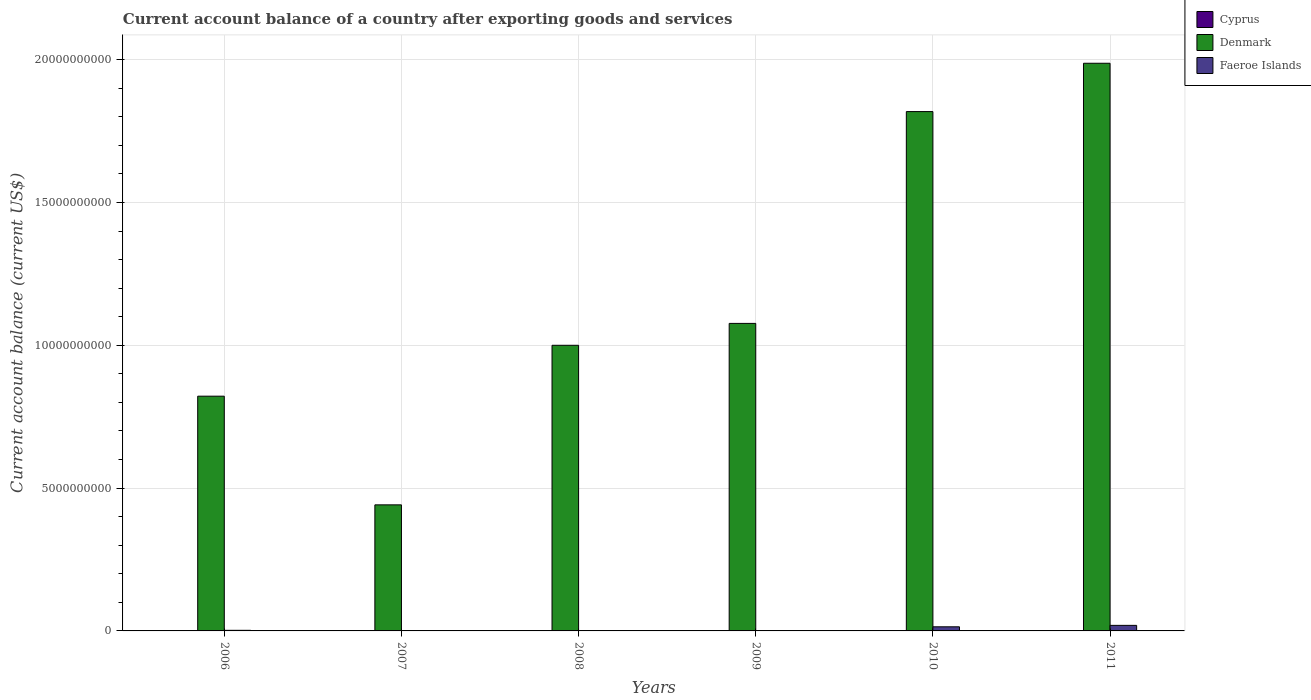How many bars are there on the 4th tick from the left?
Give a very brief answer. 1. What is the label of the 4th group of bars from the left?
Your answer should be very brief. 2009. In how many cases, is the number of bars for a given year not equal to the number of legend labels?
Your response must be concise. 6. Across all years, what is the maximum account balance in Faeroe Islands?
Provide a succinct answer. 1.94e+08. Across all years, what is the minimum account balance in Faeroe Islands?
Your response must be concise. 0. What is the total account balance in Faeroe Islands in the graph?
Your response must be concise. 3.60e+08. What is the difference between the account balance in Denmark in 2006 and that in 2007?
Your answer should be very brief. 3.80e+09. What is the difference between the account balance in Denmark in 2007 and the account balance in Faeroe Islands in 2009?
Your answer should be very brief. 4.41e+09. What is the average account balance in Denmark per year?
Your response must be concise. 1.19e+1. What is the ratio of the account balance in Denmark in 2008 to that in 2010?
Your answer should be very brief. 0.55. Is the account balance in Faeroe Islands in 2006 less than that in 2011?
Make the answer very short. Yes. Is the difference between the account balance in Faeroe Islands in 2006 and 2011 greater than the difference between the account balance in Denmark in 2006 and 2011?
Make the answer very short. Yes. What is the difference between the highest and the second highest account balance in Denmark?
Offer a terse response. 1.69e+09. What is the difference between the highest and the lowest account balance in Denmark?
Provide a short and direct response. 1.55e+1. In how many years, is the account balance in Cyprus greater than the average account balance in Cyprus taken over all years?
Keep it short and to the point. 0. Is the sum of the account balance in Denmark in 2006 and 2007 greater than the maximum account balance in Faeroe Islands across all years?
Provide a succinct answer. Yes. How many bars are there?
Provide a short and direct response. 9. How many years are there in the graph?
Give a very brief answer. 6. What is the difference between two consecutive major ticks on the Y-axis?
Keep it short and to the point. 5.00e+09. Are the values on the major ticks of Y-axis written in scientific E-notation?
Your response must be concise. No. Does the graph contain any zero values?
Ensure brevity in your answer.  Yes. How many legend labels are there?
Offer a very short reply. 3. What is the title of the graph?
Your answer should be very brief. Current account balance of a country after exporting goods and services. What is the label or title of the Y-axis?
Ensure brevity in your answer.  Current account balance (current US$). What is the Current account balance (current US$) of Denmark in 2006?
Your answer should be very brief. 8.22e+09. What is the Current account balance (current US$) of Faeroe Islands in 2006?
Give a very brief answer. 2.12e+07. What is the Current account balance (current US$) of Cyprus in 2007?
Your answer should be very brief. 0. What is the Current account balance (current US$) in Denmark in 2007?
Give a very brief answer. 4.41e+09. What is the Current account balance (current US$) in Faeroe Islands in 2007?
Provide a short and direct response. 0. What is the Current account balance (current US$) in Denmark in 2008?
Make the answer very short. 1.00e+1. What is the Current account balance (current US$) of Denmark in 2009?
Make the answer very short. 1.08e+1. What is the Current account balance (current US$) in Faeroe Islands in 2009?
Offer a very short reply. 0. What is the Current account balance (current US$) in Denmark in 2010?
Keep it short and to the point. 1.82e+1. What is the Current account balance (current US$) in Faeroe Islands in 2010?
Your answer should be very brief. 1.44e+08. What is the Current account balance (current US$) in Denmark in 2011?
Keep it short and to the point. 1.99e+1. What is the Current account balance (current US$) of Faeroe Islands in 2011?
Provide a short and direct response. 1.94e+08. Across all years, what is the maximum Current account balance (current US$) of Denmark?
Give a very brief answer. 1.99e+1. Across all years, what is the maximum Current account balance (current US$) in Faeroe Islands?
Your response must be concise. 1.94e+08. Across all years, what is the minimum Current account balance (current US$) of Denmark?
Your response must be concise. 4.41e+09. Across all years, what is the minimum Current account balance (current US$) of Faeroe Islands?
Provide a short and direct response. 0. What is the total Current account balance (current US$) of Denmark in the graph?
Provide a succinct answer. 7.15e+1. What is the total Current account balance (current US$) of Faeroe Islands in the graph?
Your answer should be compact. 3.60e+08. What is the difference between the Current account balance (current US$) in Denmark in 2006 and that in 2007?
Provide a succinct answer. 3.80e+09. What is the difference between the Current account balance (current US$) of Denmark in 2006 and that in 2008?
Provide a short and direct response. -1.78e+09. What is the difference between the Current account balance (current US$) in Denmark in 2006 and that in 2009?
Your response must be concise. -2.55e+09. What is the difference between the Current account balance (current US$) of Denmark in 2006 and that in 2010?
Offer a very short reply. -9.96e+09. What is the difference between the Current account balance (current US$) in Faeroe Islands in 2006 and that in 2010?
Ensure brevity in your answer.  -1.23e+08. What is the difference between the Current account balance (current US$) of Denmark in 2006 and that in 2011?
Give a very brief answer. -1.17e+1. What is the difference between the Current account balance (current US$) of Faeroe Islands in 2006 and that in 2011?
Keep it short and to the point. -1.73e+08. What is the difference between the Current account balance (current US$) of Denmark in 2007 and that in 2008?
Provide a short and direct response. -5.59e+09. What is the difference between the Current account balance (current US$) of Denmark in 2007 and that in 2009?
Your answer should be very brief. -6.35e+09. What is the difference between the Current account balance (current US$) of Denmark in 2007 and that in 2010?
Your answer should be very brief. -1.38e+1. What is the difference between the Current account balance (current US$) in Denmark in 2007 and that in 2011?
Your response must be concise. -1.55e+1. What is the difference between the Current account balance (current US$) of Denmark in 2008 and that in 2009?
Your answer should be compact. -7.67e+08. What is the difference between the Current account balance (current US$) in Denmark in 2008 and that in 2010?
Ensure brevity in your answer.  -8.18e+09. What is the difference between the Current account balance (current US$) in Denmark in 2008 and that in 2011?
Make the answer very short. -9.87e+09. What is the difference between the Current account balance (current US$) of Denmark in 2009 and that in 2010?
Offer a very short reply. -7.42e+09. What is the difference between the Current account balance (current US$) in Denmark in 2009 and that in 2011?
Offer a terse response. -9.11e+09. What is the difference between the Current account balance (current US$) in Denmark in 2010 and that in 2011?
Make the answer very short. -1.69e+09. What is the difference between the Current account balance (current US$) in Faeroe Islands in 2010 and that in 2011?
Provide a short and direct response. -5.00e+07. What is the difference between the Current account balance (current US$) of Denmark in 2006 and the Current account balance (current US$) of Faeroe Islands in 2010?
Your response must be concise. 8.07e+09. What is the difference between the Current account balance (current US$) in Denmark in 2006 and the Current account balance (current US$) in Faeroe Islands in 2011?
Provide a succinct answer. 8.02e+09. What is the difference between the Current account balance (current US$) in Denmark in 2007 and the Current account balance (current US$) in Faeroe Islands in 2010?
Provide a short and direct response. 4.27e+09. What is the difference between the Current account balance (current US$) of Denmark in 2007 and the Current account balance (current US$) of Faeroe Islands in 2011?
Ensure brevity in your answer.  4.22e+09. What is the difference between the Current account balance (current US$) in Denmark in 2008 and the Current account balance (current US$) in Faeroe Islands in 2010?
Keep it short and to the point. 9.86e+09. What is the difference between the Current account balance (current US$) in Denmark in 2008 and the Current account balance (current US$) in Faeroe Islands in 2011?
Provide a short and direct response. 9.81e+09. What is the difference between the Current account balance (current US$) in Denmark in 2009 and the Current account balance (current US$) in Faeroe Islands in 2010?
Your answer should be very brief. 1.06e+1. What is the difference between the Current account balance (current US$) of Denmark in 2009 and the Current account balance (current US$) of Faeroe Islands in 2011?
Provide a short and direct response. 1.06e+1. What is the difference between the Current account balance (current US$) in Denmark in 2010 and the Current account balance (current US$) in Faeroe Islands in 2011?
Make the answer very short. 1.80e+1. What is the average Current account balance (current US$) of Cyprus per year?
Offer a very short reply. 0. What is the average Current account balance (current US$) of Denmark per year?
Your response must be concise. 1.19e+1. What is the average Current account balance (current US$) of Faeroe Islands per year?
Offer a terse response. 6.00e+07. In the year 2006, what is the difference between the Current account balance (current US$) of Denmark and Current account balance (current US$) of Faeroe Islands?
Offer a terse response. 8.20e+09. In the year 2010, what is the difference between the Current account balance (current US$) in Denmark and Current account balance (current US$) in Faeroe Islands?
Provide a succinct answer. 1.80e+1. In the year 2011, what is the difference between the Current account balance (current US$) in Denmark and Current account balance (current US$) in Faeroe Islands?
Make the answer very short. 1.97e+1. What is the ratio of the Current account balance (current US$) in Denmark in 2006 to that in 2007?
Ensure brevity in your answer.  1.86. What is the ratio of the Current account balance (current US$) of Denmark in 2006 to that in 2008?
Keep it short and to the point. 0.82. What is the ratio of the Current account balance (current US$) in Denmark in 2006 to that in 2009?
Give a very brief answer. 0.76. What is the ratio of the Current account balance (current US$) of Denmark in 2006 to that in 2010?
Keep it short and to the point. 0.45. What is the ratio of the Current account balance (current US$) in Faeroe Islands in 2006 to that in 2010?
Your answer should be compact. 0.15. What is the ratio of the Current account balance (current US$) in Denmark in 2006 to that in 2011?
Provide a short and direct response. 0.41. What is the ratio of the Current account balance (current US$) of Faeroe Islands in 2006 to that in 2011?
Give a very brief answer. 0.11. What is the ratio of the Current account balance (current US$) in Denmark in 2007 to that in 2008?
Provide a short and direct response. 0.44. What is the ratio of the Current account balance (current US$) of Denmark in 2007 to that in 2009?
Provide a short and direct response. 0.41. What is the ratio of the Current account balance (current US$) in Denmark in 2007 to that in 2010?
Keep it short and to the point. 0.24. What is the ratio of the Current account balance (current US$) in Denmark in 2007 to that in 2011?
Ensure brevity in your answer.  0.22. What is the ratio of the Current account balance (current US$) of Denmark in 2008 to that in 2009?
Provide a short and direct response. 0.93. What is the ratio of the Current account balance (current US$) of Denmark in 2008 to that in 2010?
Offer a very short reply. 0.55. What is the ratio of the Current account balance (current US$) of Denmark in 2008 to that in 2011?
Offer a terse response. 0.5. What is the ratio of the Current account balance (current US$) of Denmark in 2009 to that in 2010?
Ensure brevity in your answer.  0.59. What is the ratio of the Current account balance (current US$) in Denmark in 2009 to that in 2011?
Your response must be concise. 0.54. What is the ratio of the Current account balance (current US$) in Denmark in 2010 to that in 2011?
Your answer should be compact. 0.91. What is the ratio of the Current account balance (current US$) in Faeroe Islands in 2010 to that in 2011?
Your response must be concise. 0.74. What is the difference between the highest and the second highest Current account balance (current US$) of Denmark?
Provide a short and direct response. 1.69e+09. What is the difference between the highest and the second highest Current account balance (current US$) of Faeroe Islands?
Offer a terse response. 5.00e+07. What is the difference between the highest and the lowest Current account balance (current US$) of Denmark?
Your response must be concise. 1.55e+1. What is the difference between the highest and the lowest Current account balance (current US$) of Faeroe Islands?
Keep it short and to the point. 1.94e+08. 